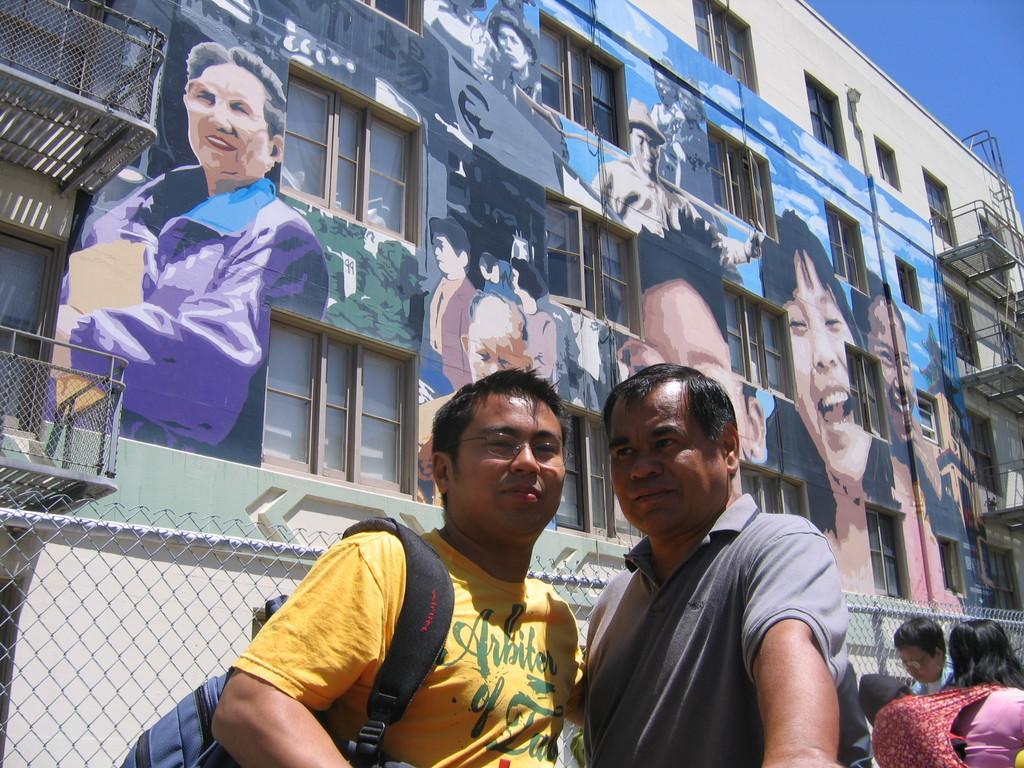In one or two sentences, can you explain what this image depicts? In this picture we can see two men standing in the front, a man on the left side is carrying a backpack, on the right side there are two more persons, in the background there is a building, we can see railings and windows of the building, we can also see wall painting where, there is sky at the right top of the image. 